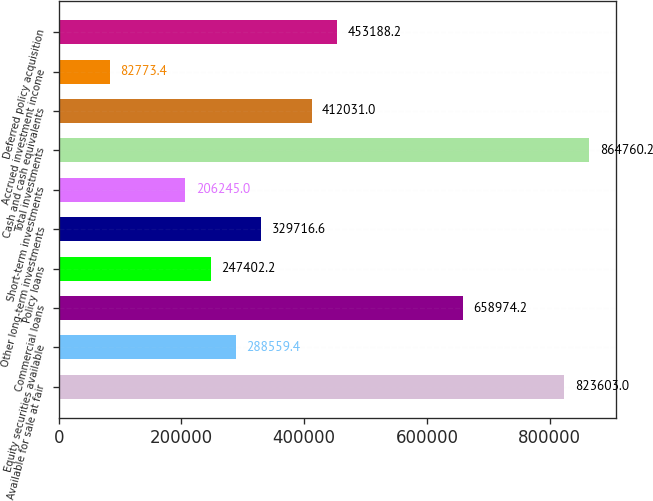Convert chart to OTSL. <chart><loc_0><loc_0><loc_500><loc_500><bar_chart><fcel>Available for sale at fair<fcel>Equity securities available<fcel>Commercial loans<fcel>Policy loans<fcel>Other long-term investments<fcel>Short-term investments<fcel>Total investments<fcel>Cash and cash equivalents<fcel>Accrued investment income<fcel>Deferred policy acquisition<nl><fcel>823603<fcel>288559<fcel>658974<fcel>247402<fcel>329717<fcel>206245<fcel>864760<fcel>412031<fcel>82773.4<fcel>453188<nl></chart> 